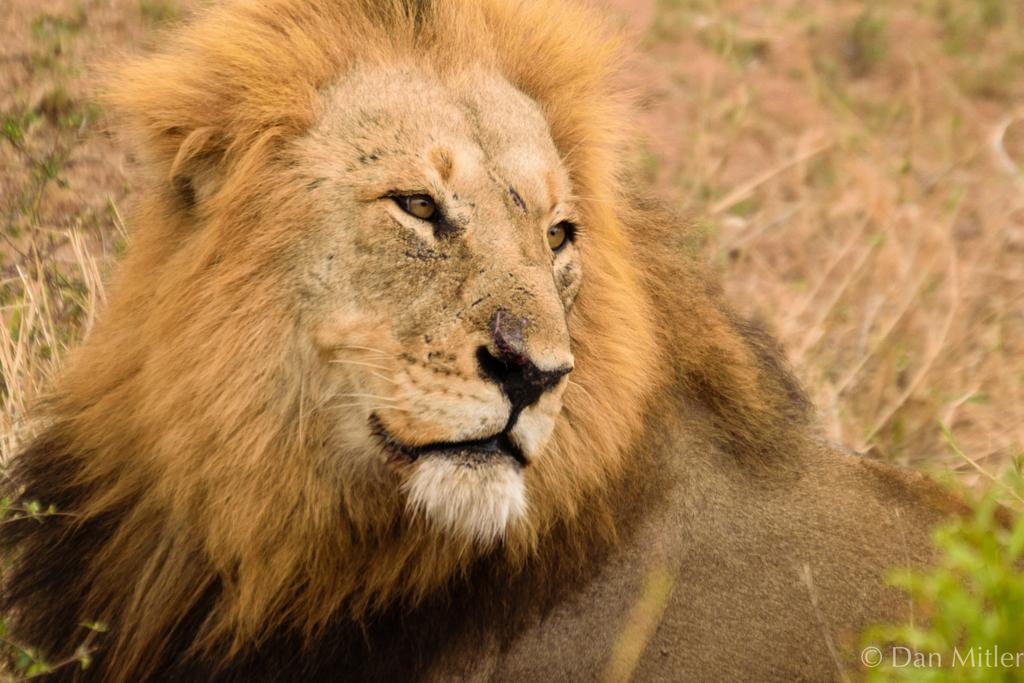What animal is the main subject of the image? There is a lion in the image. What can be seen in the background behind the lion? There are plants visible behind the lion. Where are the leaves located in the image? The leaves are in the bottom right of the image. What is the nature of the text in the image? There is some text in the image. What type of belief is represented by the snow in the image? There is no snow present in the image, so it cannot be used to represent any belief. 